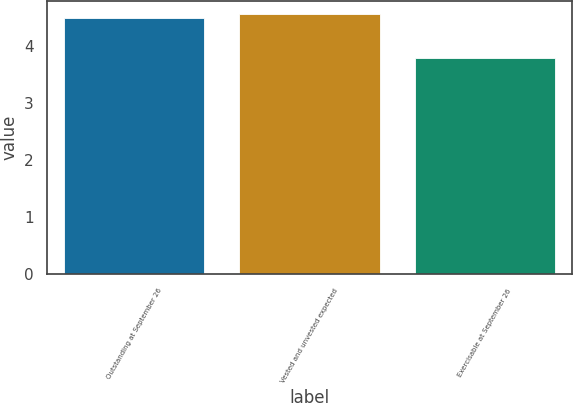Convert chart. <chart><loc_0><loc_0><loc_500><loc_500><bar_chart><fcel>Outstanding at September 26<fcel>Vested and unvested expected<fcel>Exercisable at September 26<nl><fcel>4.5<fcel>4.57<fcel>3.8<nl></chart> 